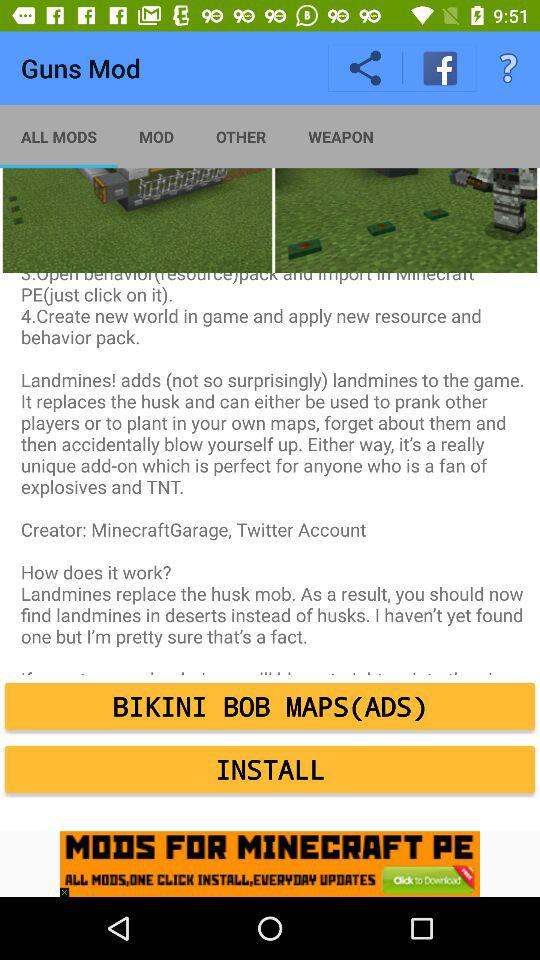What is the name of the application? The name of the application is "Guns Mod". 